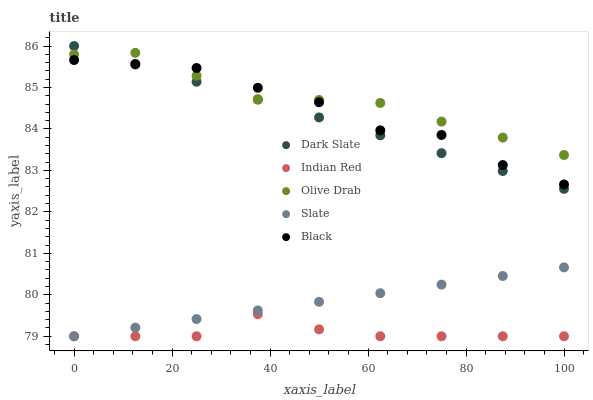Does Indian Red have the minimum area under the curve?
Answer yes or no. Yes. Does Olive Drab have the maximum area under the curve?
Answer yes or no. Yes. Does Slate have the minimum area under the curve?
Answer yes or no. No. Does Slate have the maximum area under the curve?
Answer yes or no. No. Is Slate the smoothest?
Answer yes or no. Yes. Is Black the roughest?
Answer yes or no. Yes. Is Black the smoothest?
Answer yes or no. No. Is Slate the roughest?
Answer yes or no. No. Does Slate have the lowest value?
Answer yes or no. Yes. Does Black have the lowest value?
Answer yes or no. No. Does Dark Slate have the highest value?
Answer yes or no. Yes. Does Slate have the highest value?
Answer yes or no. No. Is Slate less than Black?
Answer yes or no. Yes. Is Olive Drab greater than Slate?
Answer yes or no. Yes. Does Dark Slate intersect Olive Drab?
Answer yes or no. Yes. Is Dark Slate less than Olive Drab?
Answer yes or no. No. Is Dark Slate greater than Olive Drab?
Answer yes or no. No. Does Slate intersect Black?
Answer yes or no. No. 